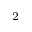<formula> <loc_0><loc_0><loc_500><loc_500>_ { 2 }</formula> 